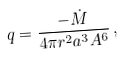Convert formula to latex. <formula><loc_0><loc_0><loc_500><loc_500>q = \frac { - \dot { M } } { 4 \pi r ^ { 2 } a ^ { 3 } A ^ { 6 } } \, ,</formula> 